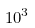<formula> <loc_0><loc_0><loc_500><loc_500>1 0 ^ { 3 }</formula> 